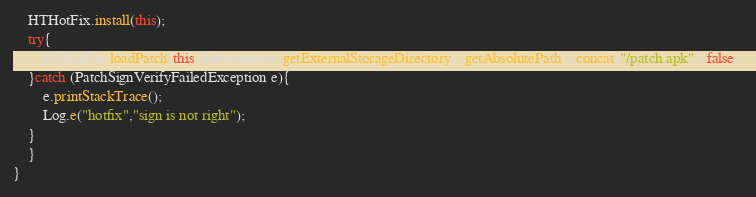Convert code to text. <code><loc_0><loc_0><loc_500><loc_500><_Java_>    HTHotFix.install(this);
    try{
        HTHotFix.loadPatch(this, Environment.getExternalStorageDirectory().getAbsolutePath().concat("/patch.apk"), false);
    }catch (PatchSignVerifyFailedException e){
        e.printStackTrace();
        Log.e("hotfix","sign is not right");
    }
    }
}
</code> 